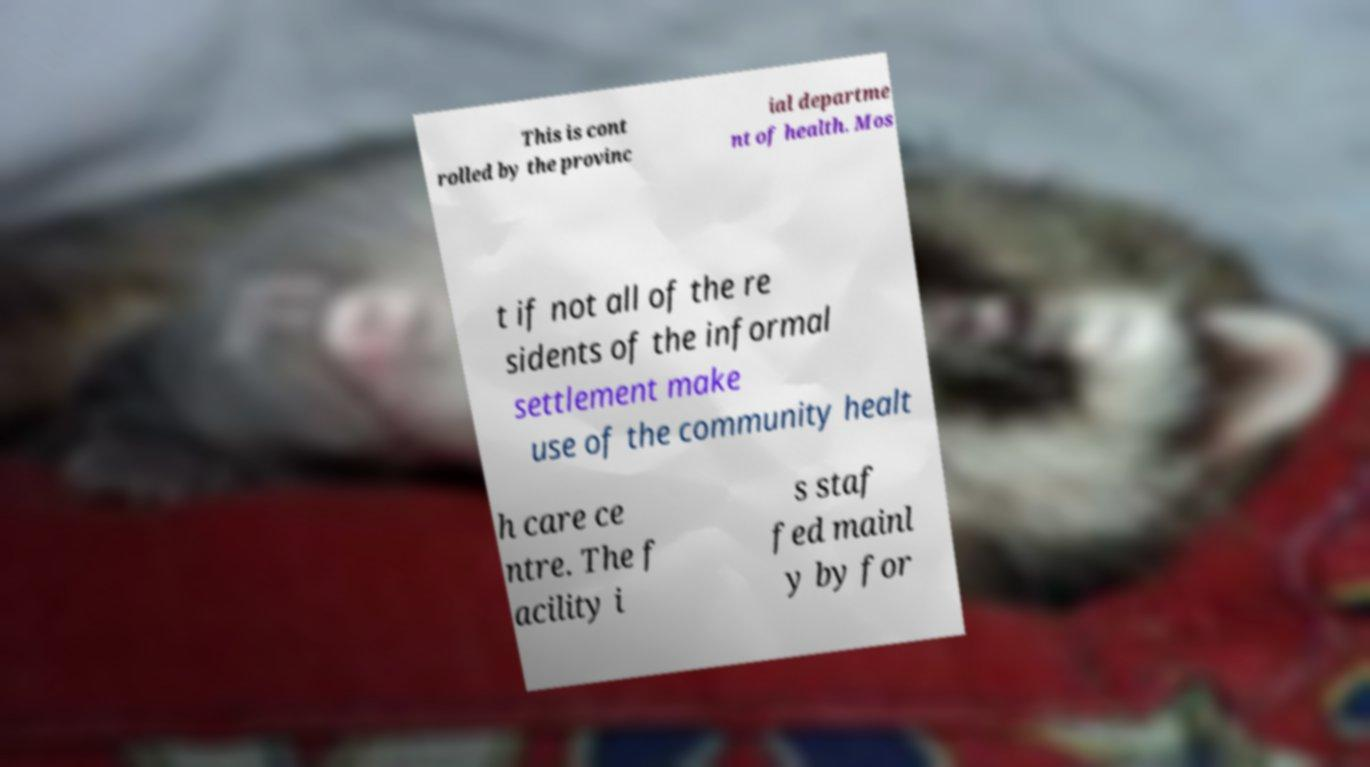Could you assist in decoding the text presented in this image and type it out clearly? This is cont rolled by the provinc ial departme nt of health. Mos t if not all of the re sidents of the informal settlement make use of the community healt h care ce ntre. The f acility i s staf fed mainl y by for 